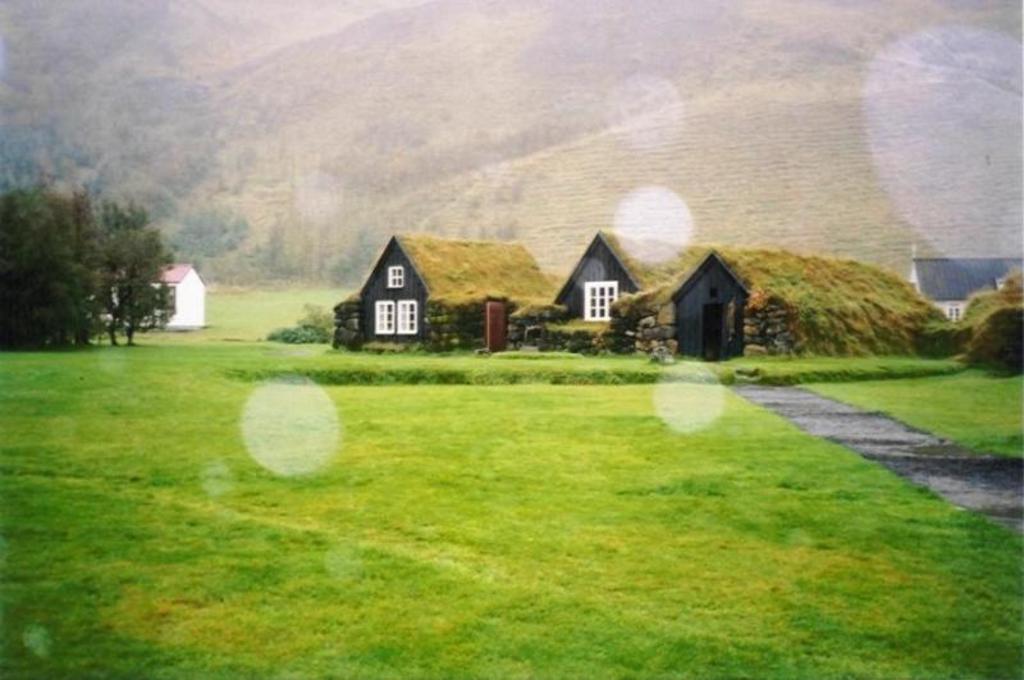In one or two sentences, can you explain what this image depicts? In the center of the image there are buildings. There are Trees. At the bottom of the image there is grass on the surface. On the right side of the image there is a road and the background of the image is blur. 